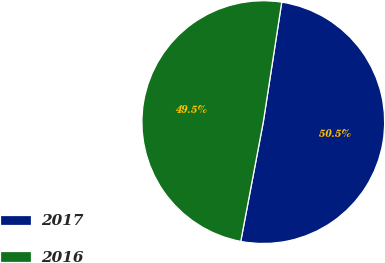Convert chart. <chart><loc_0><loc_0><loc_500><loc_500><pie_chart><fcel>2017<fcel>2016<nl><fcel>50.54%<fcel>49.46%<nl></chart> 